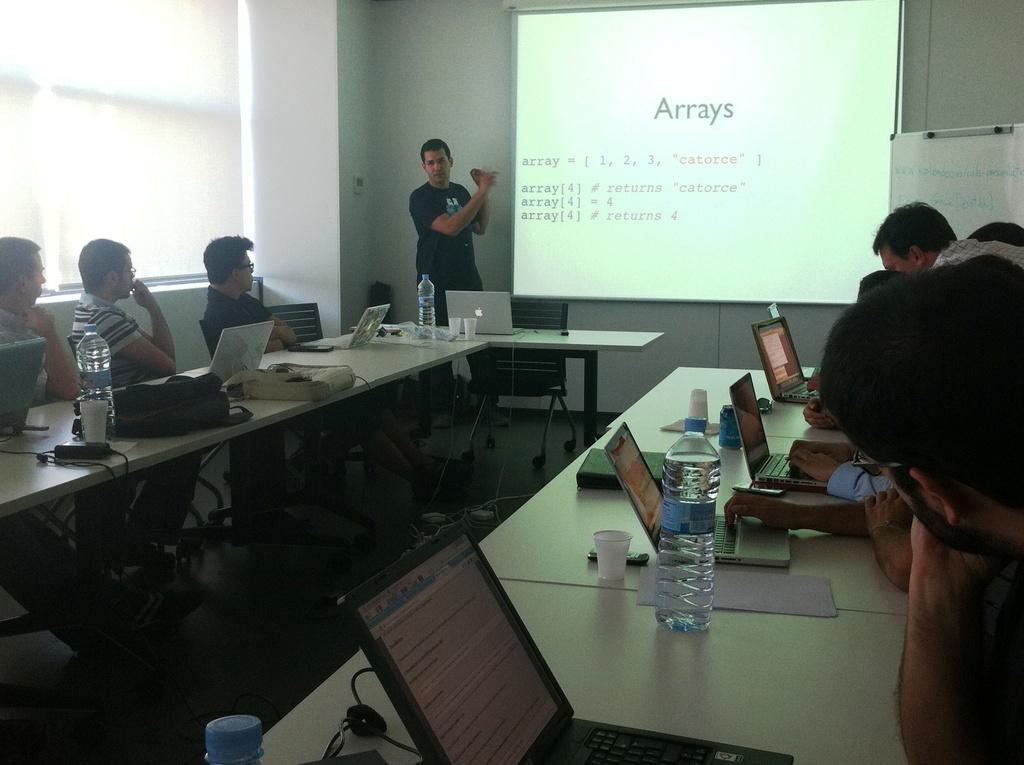Provide a one-sentence caption for the provided image. A group of people seated around tables containing laptops while looking at a screen displaying information about Arrays. 